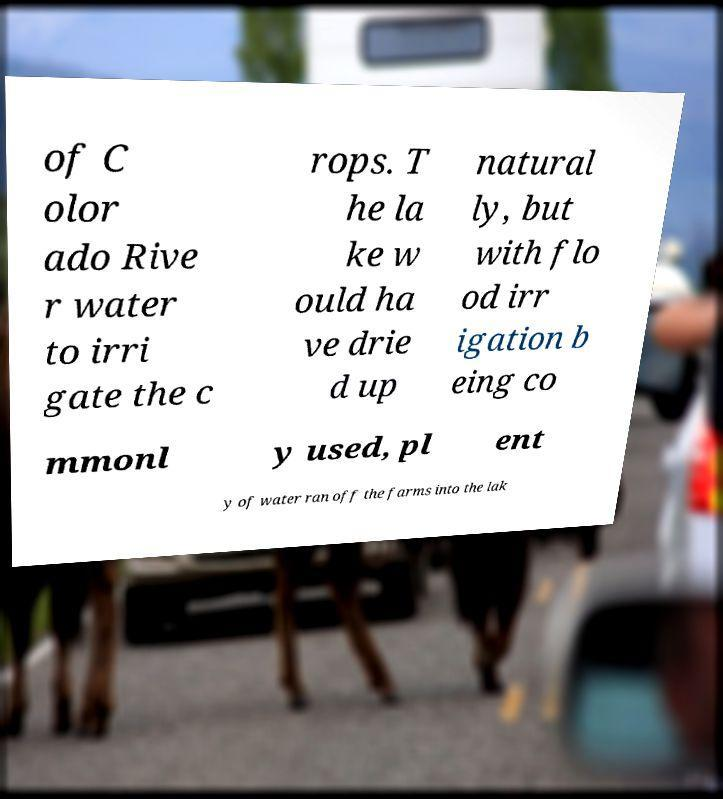There's text embedded in this image that I need extracted. Can you transcribe it verbatim? of C olor ado Rive r water to irri gate the c rops. T he la ke w ould ha ve drie d up natural ly, but with flo od irr igation b eing co mmonl y used, pl ent y of water ran off the farms into the lak 